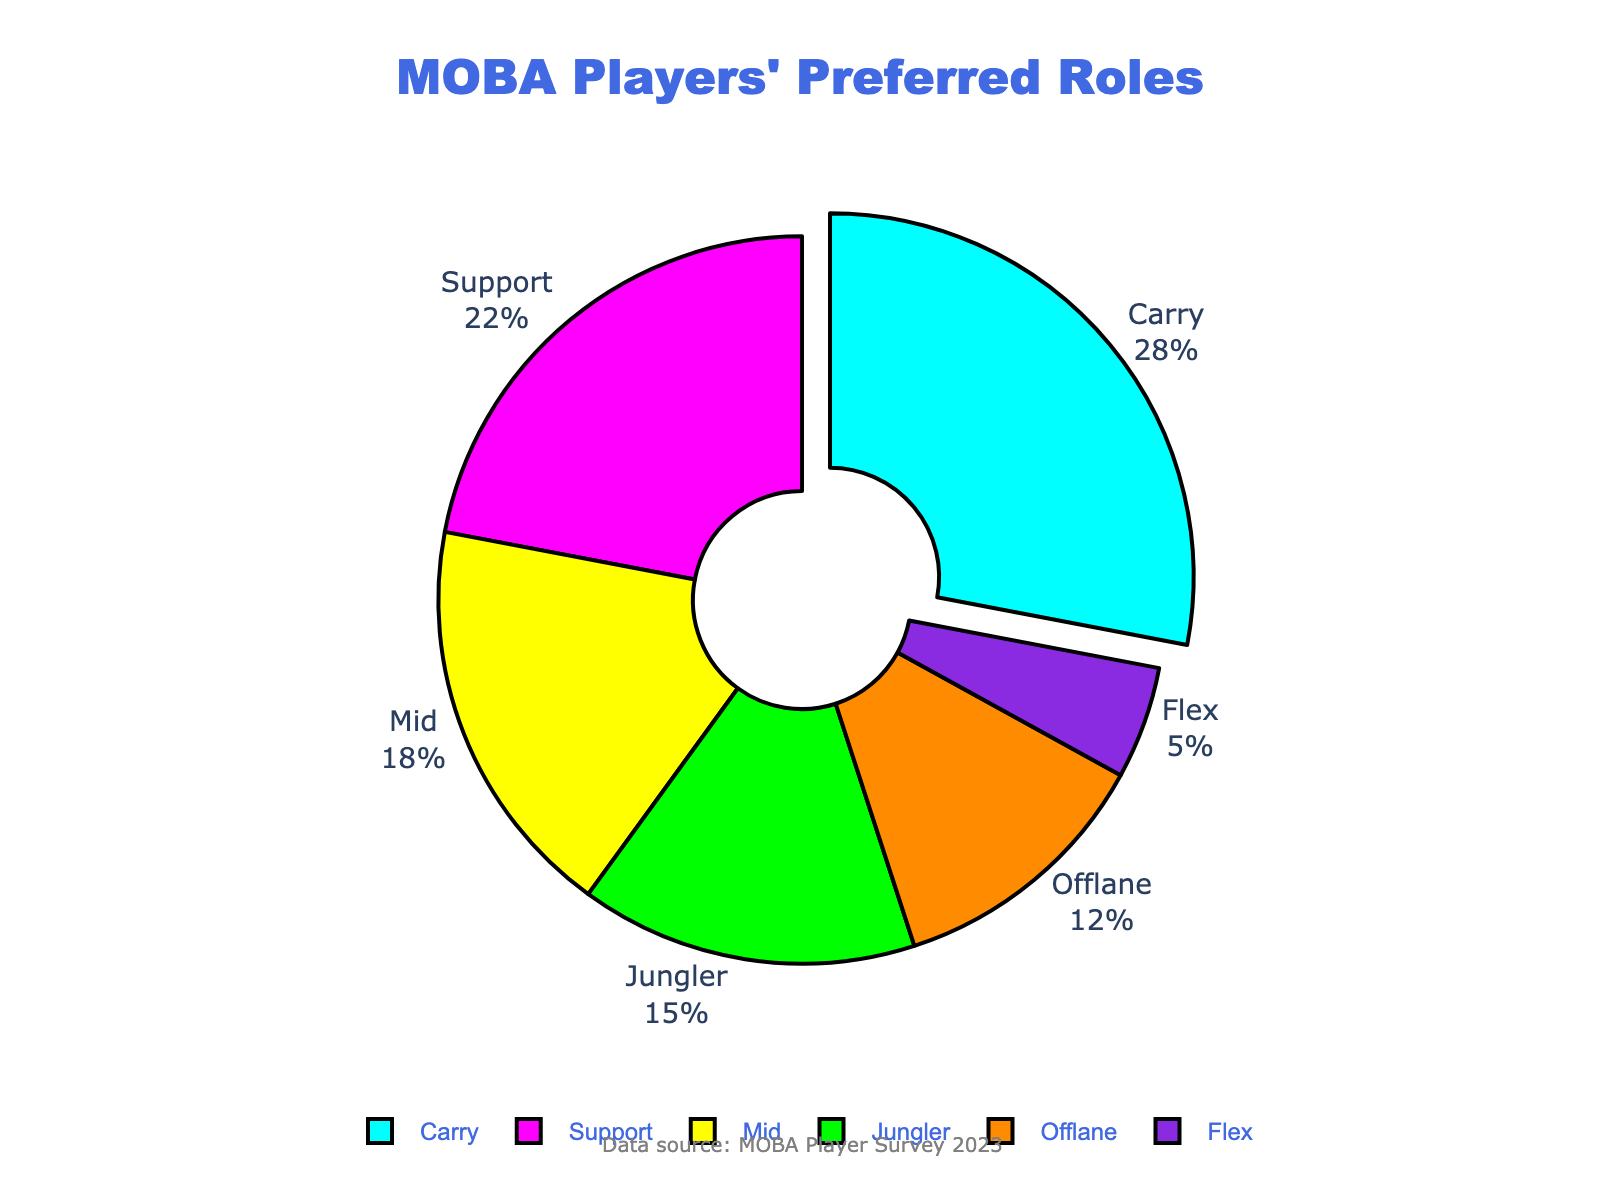Which role has the highest percentage of MOBA players' preference? The figure shows the percentage of players' preferences for each role. The slice for "Carry" is the largest, indicating the highest percentage.
Answer: Carry Which role is preferred by the smallest percentage of players? The pie chart displays the slices of different sizes corresponding to each role. The "Flex" role has the smallest slice.
Answer: Flex What is the combined percentage of players who prefer Carry and Support roles? The figure indicates that Carry is 28% and Support is 22%. Combining these, we get 28% + 22% = 50%.
Answer: 50% Are there more players who prefer Mid role compared to Offlane role? The figure shows the percentage for Mid as 18% and Offlane as 12%. Since 18% is greater than 12%, there are more players who prefer Mid.
Answer: Yes What is the difference in player preference between Jungler and Offlane roles? The figure shows the percentage for Jungler as 15% and Offlane as 12%. The difference is 15% - 12% = 3%.
Answer: 3% Is the percentage of players who prefer Support roles greater than those who prefer Jungler and Offlane roles combined? The figure shows Support at 22%, Jungler at 15%, and Offlane at 12%. The combined Jungler and Offlane is 15% + 12% = 27%, which is greater than 22%.
Answer: No Which role has a slice colored with a shade of blue? The pie chart uses different colors for each slice. The slice colored in a shade of blue is for the "Offlane" role.
Answer: Offlane What is the average percentage of players for Carry, Support, and Mid roles? The percentages are 28% (Carry), 22% (Support), and 18% (Mid). The average is (28 + 22 + 18) / 3 = 68 / 3 ≈ 22.67%.
Answer: 22.67% How much larger is the slice for Carry compared to the slice for Flex? The figure shows the percentage for Carry as 28% and for Flex as 5%. The difference is 28% - 5% = 23%.
Answer: 23% Which role has a larger percentage: Jungler or Mid? The figure shows Mid at 18% and Jungler at 15%. Since 18% is greater than 15%, Mid has a larger percentage.
Answer: Mid 